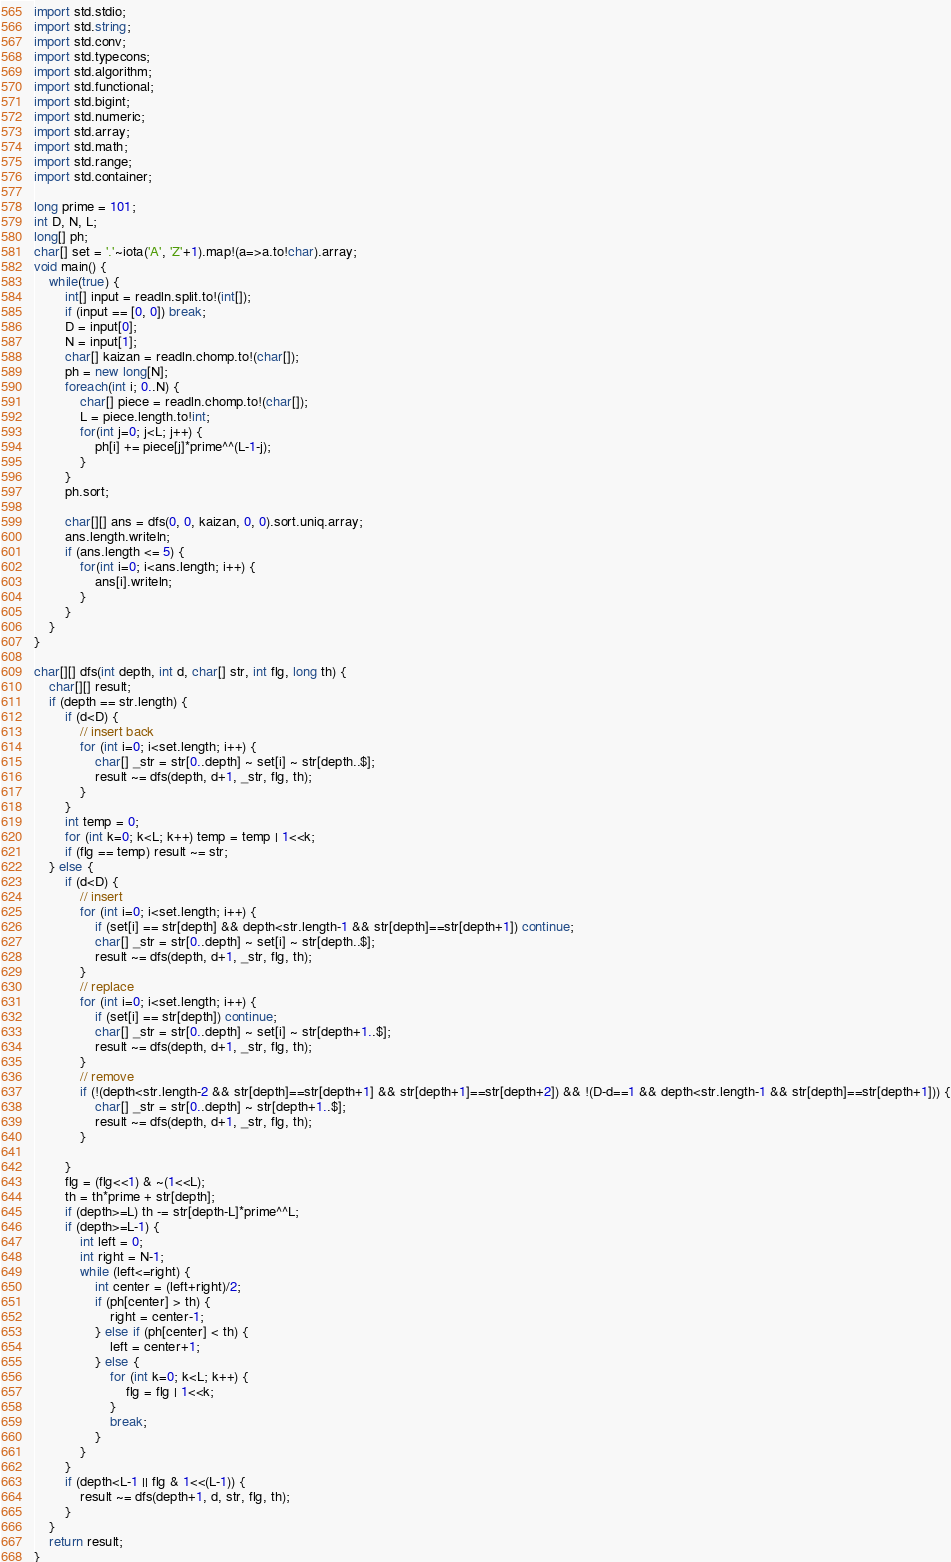Convert code to text. <code><loc_0><loc_0><loc_500><loc_500><_D_>import std.stdio;
import std.string;
import std.conv;
import std.typecons;
import std.algorithm;
import std.functional;
import std.bigint;
import std.numeric;
import std.array;
import std.math;
import std.range;
import std.container;

long prime = 101;
int D, N, L;
long[] ph;
char[] set = '.'~iota('A', 'Z'+1).map!(a=>a.to!char).array;
void main() {
    while(true) {
        int[] input = readln.split.to!(int[]);
        if (input == [0, 0]) break;
        D = input[0];
        N = input[1];
        char[] kaizan = readln.chomp.to!(char[]);
        ph = new long[N];
        foreach(int i; 0..N) {
            char[] piece = readln.chomp.to!(char[]);
            L = piece.length.to!int;
            for(int j=0; j<L; j++) {
                ph[i] += piece[j]*prime^^(L-1-j);
            }
        }
        ph.sort;

        char[][] ans = dfs(0, 0, kaizan, 0, 0).sort.uniq.array;
        ans.length.writeln;
        if (ans.length <= 5) {
            for(int i=0; i<ans.length; i++) {
                ans[i].writeln;
            }
        }
    }
}

char[][] dfs(int depth, int d, char[] str, int flg, long th) {
    char[][] result;
    if (depth == str.length) {
        if (d<D) {
            // insert back
            for (int i=0; i<set.length; i++) {
                char[] _str = str[0..depth] ~ set[i] ~ str[depth..$];
                result ~= dfs(depth, d+1, _str, flg, th);
            }
        }
        int temp = 0;
        for (int k=0; k<L; k++) temp = temp | 1<<k;
        if (flg == temp) result ~= str;
    } else {
        if (d<D) {
            // insert
            for (int i=0; i<set.length; i++) {
                if (set[i] == str[depth] && depth<str.length-1 && str[depth]==str[depth+1]) continue;
                char[] _str = str[0..depth] ~ set[i] ~ str[depth..$];
                result ~= dfs(depth, d+1, _str, flg, th);
            }
            // replace
            for (int i=0; i<set.length; i++) {
                if (set[i] == str[depth]) continue;
                char[] _str = str[0..depth] ~ set[i] ~ str[depth+1..$];
                result ~= dfs(depth, d+1, _str, flg, th);
            }
            // remove
            if (!(depth<str.length-2 && str[depth]==str[depth+1] && str[depth+1]==str[depth+2]) && !(D-d==1 && depth<str.length-1 && str[depth]==str[depth+1])) {
                char[] _str = str[0..depth] ~ str[depth+1..$];
                result ~= dfs(depth, d+1, _str, flg, th);
            }

        }
        flg = (flg<<1) & ~(1<<L);
        th = th*prime + str[depth];
        if (depth>=L) th -= str[depth-L]*prime^^L;
        if (depth>=L-1) {
            int left = 0;
            int right = N-1;
            while (left<=right) {
                int center = (left+right)/2;
                if (ph[center] > th) {
                    right = center-1;
                } else if (ph[center] < th) {
                    left = center+1;
                } else {
                    for (int k=0; k<L; k++) {
                        flg = flg | 1<<k;
                    }
                    break;
                }
            }
        }
        if (depth<L-1 || flg & 1<<(L-1)) {
            result ~= dfs(depth+1, d, str, flg, th);
        }
    }
    return result;
}</code> 